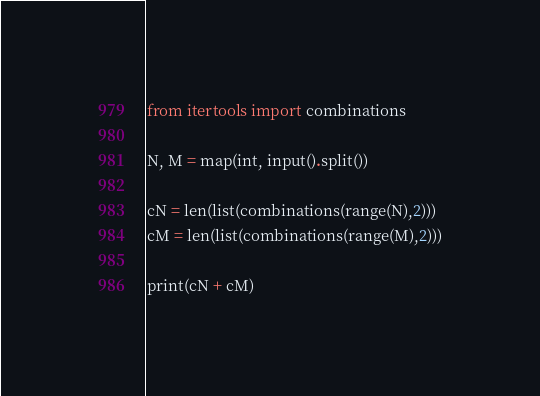<code> <loc_0><loc_0><loc_500><loc_500><_Python_>from itertools import combinations

N, M = map(int, input().split())

cN = len(list(combinations(range(N),2)))
cM = len(list(combinations(range(M),2)))

print(cN + cM)
</code> 